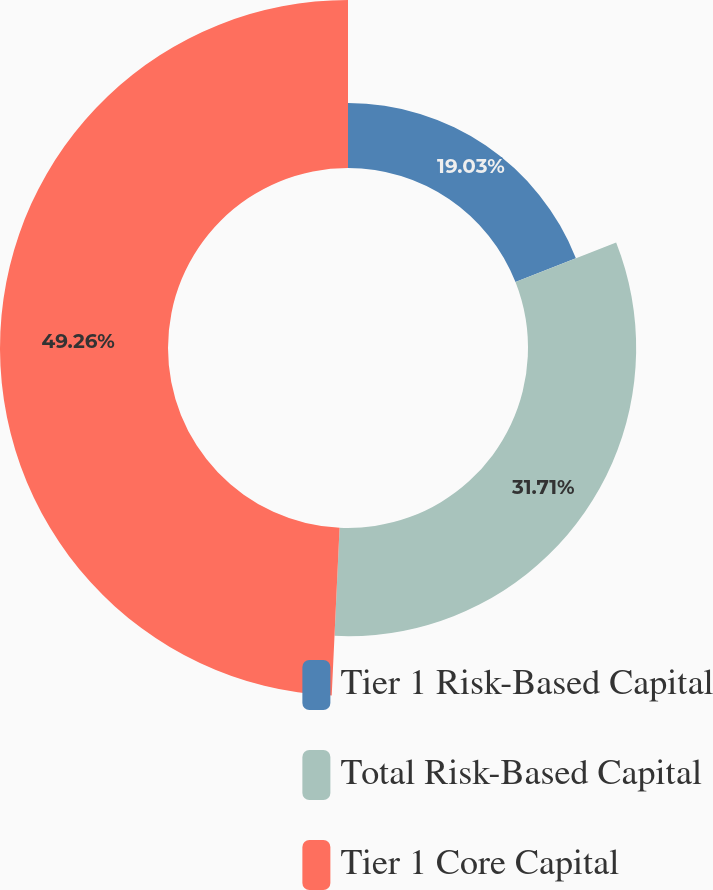<chart> <loc_0><loc_0><loc_500><loc_500><pie_chart><fcel>Tier 1 Risk-Based Capital<fcel>Total Risk-Based Capital<fcel>Tier 1 Core Capital<nl><fcel>19.03%<fcel>31.71%<fcel>49.25%<nl></chart> 